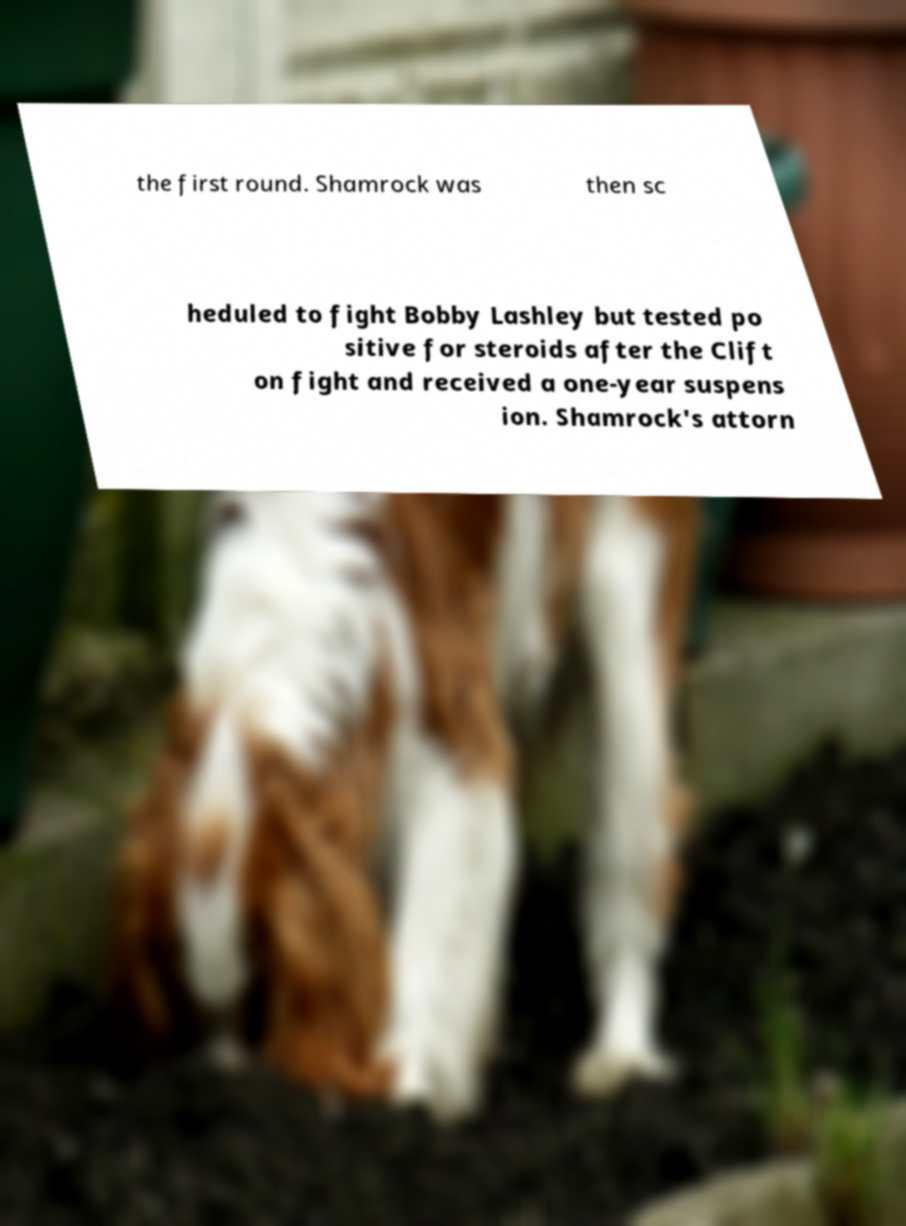Can you accurately transcribe the text from the provided image for me? the first round. Shamrock was then sc heduled to fight Bobby Lashley but tested po sitive for steroids after the Clift on fight and received a one-year suspens ion. Shamrock's attorn 